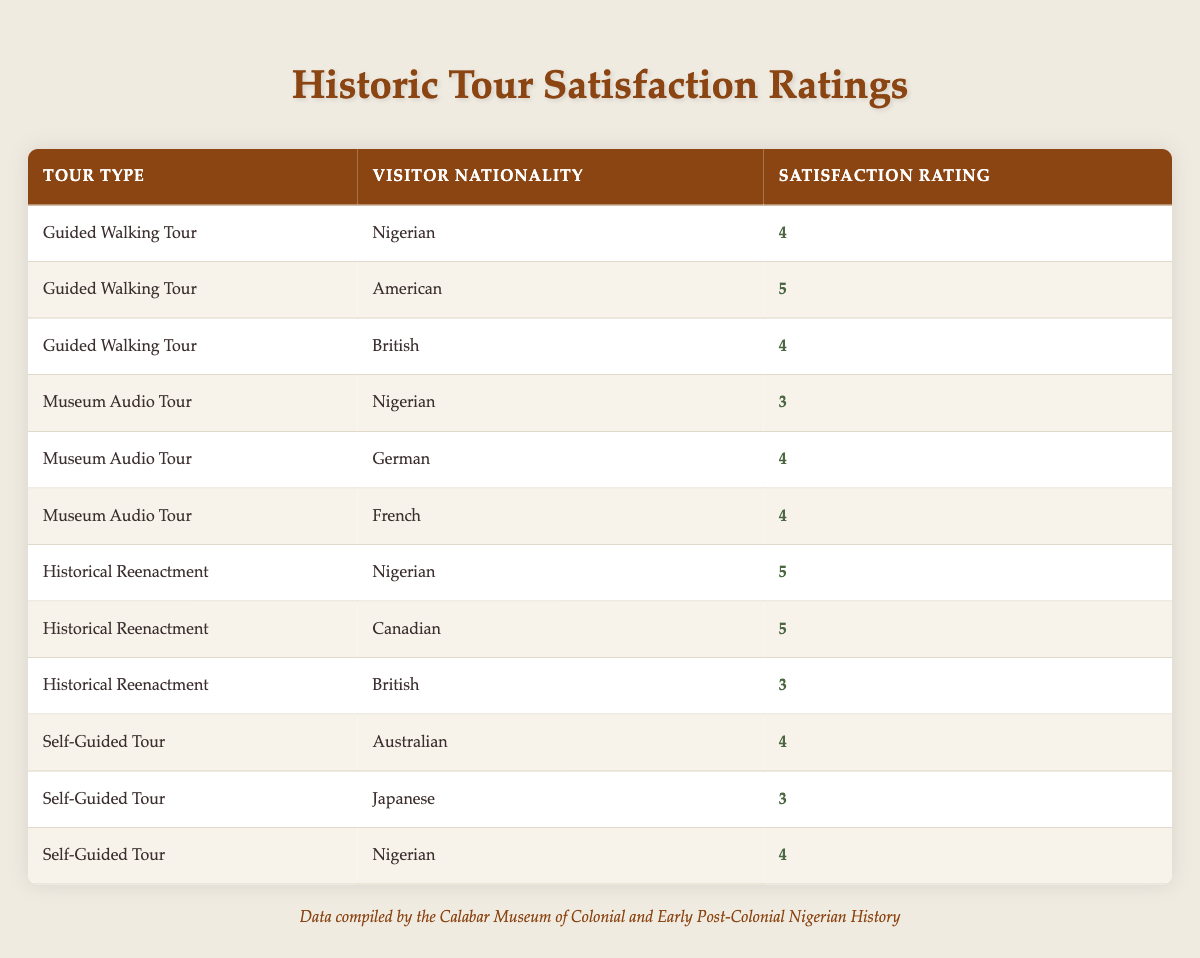What is the satisfaction rating of the Guided Walking Tour for American visitors? The table clearly shows a row for the Guided Walking Tour with the Visitor Nationality as American, which states the Satisfaction Rating as 5.
Answer: 5 Which nationality had the lowest satisfaction rating for the Museum Audio Tour? In the table, the Museum Audio Tour has ratings from three nationalities: Nigerian (3), German (4), and French (4). The lowest is the Nigerian rating of 3.
Answer: Nigerian What is the average satisfaction rating for the Historical Reenactment tours? For Historical Reenactment, the satisfaction ratings are: Nigerian (5), Canadian (5), and British (3). The sum is (5 + 5 + 3 = 13), and there are 3 ratings, so the average is 13/3 ≈ 4.33.
Answer: 4.33 Did more nationalities give a satisfaction rating of 4 compared to 5 for the Guided Walking Tour? The ratings for the Guided Walking Tour are: Nigerian (4), American (5), and British (4). There are 2 ratings of 4 and 1 rating of 5, indicating that more nationalities rated it 4.
Answer: Yes What is the overall satisfaction rating for Nigerian visitors across all tours? The Nigerian ratings from the table are: Guided Walking Tour (4), Museum Audio Tour (3), Historical Reenactment (5), and Self-Guided Tour (4). Summing these gives (4 + 3 + 5 + 4 = 16) across 4 tours, resulting in an average of 16/4 = 4.
Answer: 4 